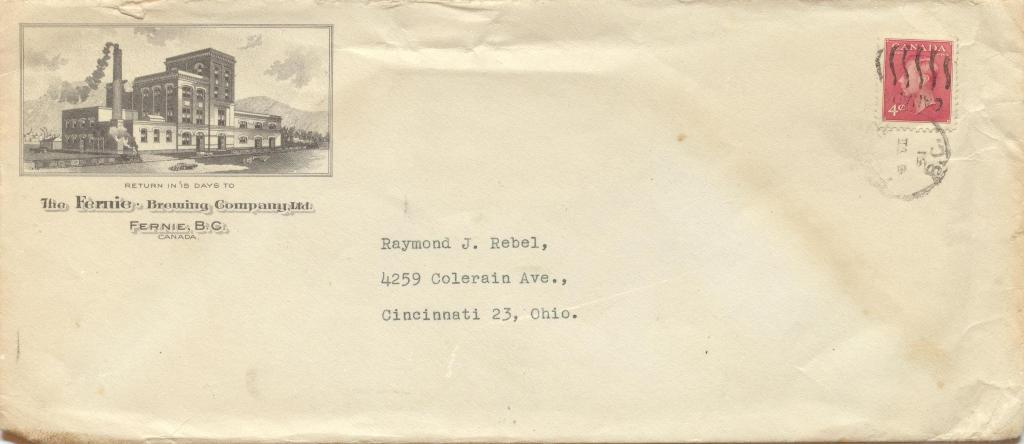What is the main object in the image? There is a letter cover in the image. What can be seen on the letter cover? The letter cover has a stamp on it and an image of a building. Is there any text on the letter cover? Yes, there is text on the letter cover. How does the locket on the letter cover balance the weight of the stamp? There is no locket present on the letter cover; it only has a stamp and an image of a building. 